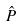<formula> <loc_0><loc_0><loc_500><loc_500>\hat { P }</formula> 